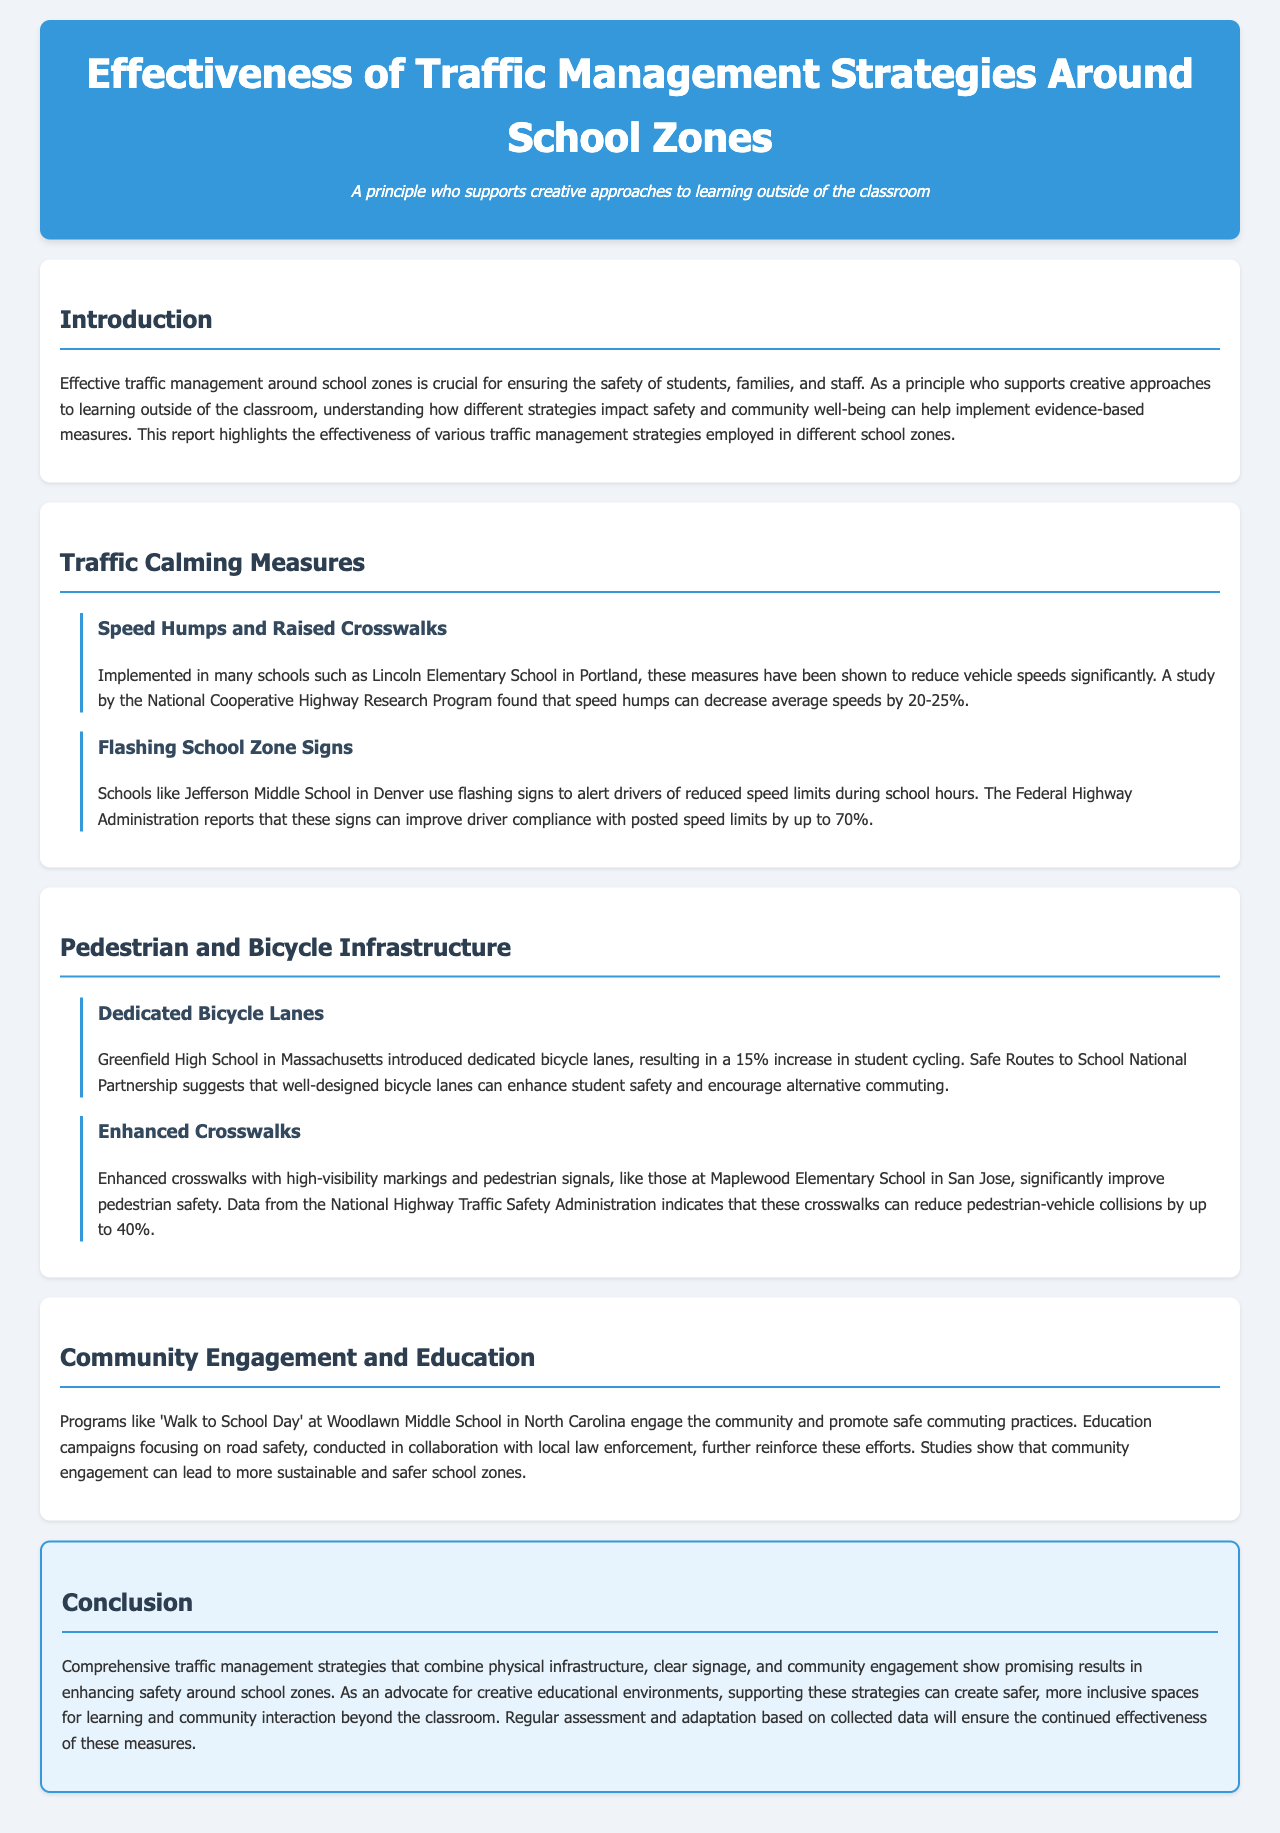What is the title of the report? The title of the report is prominently displayed in the header section.
Answer: Effectiveness of Traffic Management Strategies Around School Zones Which school used speed humps to reduce vehicle speeds? The document identifies Lincoln Elementary School in Portland as one that implemented speed humps.
Answer: Lincoln Elementary School What is the percentage decrease in vehicle speeds due to speed humps? The report states that speed humps can decrease average speeds by 20-25%.
Answer: 20-25% Which school implemented dedicated bicycle lanes? The report mentions Greenfield High School in Massachusetts as the school that introduced dedicated bicycle lanes.
Answer: Greenfield High School By what percentage did student cycling increase at Greenfield High School? The introduction of dedicated bicycle lanes resulted in a 15% increase in student cycling.
Answer: 15% What is the impact of flashing school zone signs according to the Federal Highway Administration? The document reports that flashing signs can improve driver compliance by up to 70%.
Answer: 70% What is the effect of enhanced crosswalks on pedestrian-vehicle collisions? According to data from the National Highway Traffic Safety Administration, enhanced crosswalks can reduce pedestrian-vehicle collisions by up to 40%.
Answer: 40% What program at Woodlawn Middle School promotes safe commuting? The document mentions 'Walk to School Day' as a program that promotes safe commuting practices.
Answer: Walk to School Day What is the main theme of the conclusion in the report? The conclusion emphasizes the importance of comprehensive traffic management strategies combining various measures for enhanced safety.
Answer: Comprehensive traffic management strategies 